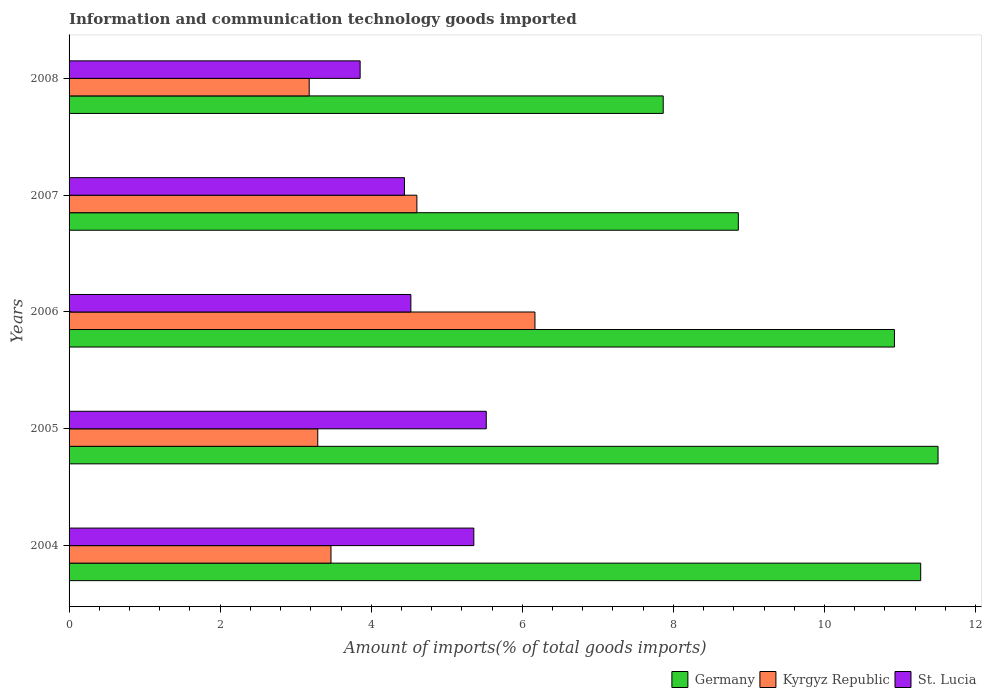How many different coloured bars are there?
Your response must be concise. 3. How many groups of bars are there?
Offer a terse response. 5. Are the number of bars per tick equal to the number of legend labels?
Your answer should be very brief. Yes. What is the label of the 2nd group of bars from the top?
Give a very brief answer. 2007. What is the amount of goods imported in Kyrgyz Republic in 2008?
Provide a short and direct response. 3.18. Across all years, what is the maximum amount of goods imported in Kyrgyz Republic?
Your answer should be very brief. 6.17. Across all years, what is the minimum amount of goods imported in Kyrgyz Republic?
Provide a succinct answer. 3.18. What is the total amount of goods imported in Kyrgyz Republic in the graph?
Provide a succinct answer. 20.71. What is the difference between the amount of goods imported in St. Lucia in 2004 and that in 2006?
Ensure brevity in your answer.  0.83. What is the difference between the amount of goods imported in St. Lucia in 2006 and the amount of goods imported in Germany in 2005?
Your answer should be compact. -6.98. What is the average amount of goods imported in Kyrgyz Republic per year?
Make the answer very short. 4.14. In the year 2008, what is the difference between the amount of goods imported in St. Lucia and amount of goods imported in Kyrgyz Republic?
Your answer should be compact. 0.67. What is the ratio of the amount of goods imported in Germany in 2007 to that in 2008?
Offer a terse response. 1.13. Is the difference between the amount of goods imported in St. Lucia in 2007 and 2008 greater than the difference between the amount of goods imported in Kyrgyz Republic in 2007 and 2008?
Give a very brief answer. No. What is the difference between the highest and the second highest amount of goods imported in Kyrgyz Republic?
Keep it short and to the point. 1.56. What is the difference between the highest and the lowest amount of goods imported in Kyrgyz Republic?
Offer a very short reply. 2.99. In how many years, is the amount of goods imported in St. Lucia greater than the average amount of goods imported in St. Lucia taken over all years?
Your answer should be very brief. 2. Is the sum of the amount of goods imported in St. Lucia in 2004 and 2006 greater than the maximum amount of goods imported in Kyrgyz Republic across all years?
Your answer should be compact. Yes. What does the 3rd bar from the top in 2004 represents?
Give a very brief answer. Germany. Is it the case that in every year, the sum of the amount of goods imported in St. Lucia and amount of goods imported in Germany is greater than the amount of goods imported in Kyrgyz Republic?
Make the answer very short. Yes. Are the values on the major ticks of X-axis written in scientific E-notation?
Provide a short and direct response. No. Does the graph contain any zero values?
Your answer should be very brief. No. Where does the legend appear in the graph?
Keep it short and to the point. Bottom right. What is the title of the graph?
Your answer should be compact. Information and communication technology goods imported. What is the label or title of the X-axis?
Ensure brevity in your answer.  Amount of imports(% of total goods imports). What is the label or title of the Y-axis?
Offer a terse response. Years. What is the Amount of imports(% of total goods imports) in Germany in 2004?
Give a very brief answer. 11.27. What is the Amount of imports(% of total goods imports) of Kyrgyz Republic in 2004?
Your answer should be very brief. 3.47. What is the Amount of imports(% of total goods imports) of St. Lucia in 2004?
Offer a terse response. 5.36. What is the Amount of imports(% of total goods imports) in Germany in 2005?
Offer a very short reply. 11.5. What is the Amount of imports(% of total goods imports) in Kyrgyz Republic in 2005?
Offer a terse response. 3.29. What is the Amount of imports(% of total goods imports) in St. Lucia in 2005?
Keep it short and to the point. 5.52. What is the Amount of imports(% of total goods imports) in Germany in 2006?
Make the answer very short. 10.93. What is the Amount of imports(% of total goods imports) of Kyrgyz Republic in 2006?
Offer a very short reply. 6.17. What is the Amount of imports(% of total goods imports) of St. Lucia in 2006?
Your answer should be very brief. 4.53. What is the Amount of imports(% of total goods imports) of Germany in 2007?
Make the answer very short. 8.86. What is the Amount of imports(% of total goods imports) in Kyrgyz Republic in 2007?
Ensure brevity in your answer.  4.6. What is the Amount of imports(% of total goods imports) of St. Lucia in 2007?
Your response must be concise. 4.44. What is the Amount of imports(% of total goods imports) in Germany in 2008?
Make the answer very short. 7.87. What is the Amount of imports(% of total goods imports) in Kyrgyz Republic in 2008?
Offer a terse response. 3.18. What is the Amount of imports(% of total goods imports) in St. Lucia in 2008?
Make the answer very short. 3.85. Across all years, what is the maximum Amount of imports(% of total goods imports) in Germany?
Provide a short and direct response. 11.5. Across all years, what is the maximum Amount of imports(% of total goods imports) in Kyrgyz Republic?
Provide a succinct answer. 6.17. Across all years, what is the maximum Amount of imports(% of total goods imports) of St. Lucia?
Provide a short and direct response. 5.52. Across all years, what is the minimum Amount of imports(% of total goods imports) in Germany?
Your answer should be very brief. 7.87. Across all years, what is the minimum Amount of imports(% of total goods imports) of Kyrgyz Republic?
Your answer should be very brief. 3.18. Across all years, what is the minimum Amount of imports(% of total goods imports) of St. Lucia?
Keep it short and to the point. 3.85. What is the total Amount of imports(% of total goods imports) in Germany in the graph?
Offer a very short reply. 50.43. What is the total Amount of imports(% of total goods imports) of Kyrgyz Republic in the graph?
Offer a terse response. 20.71. What is the total Amount of imports(% of total goods imports) of St. Lucia in the graph?
Make the answer very short. 23.7. What is the difference between the Amount of imports(% of total goods imports) in Germany in 2004 and that in 2005?
Make the answer very short. -0.23. What is the difference between the Amount of imports(% of total goods imports) of Kyrgyz Republic in 2004 and that in 2005?
Give a very brief answer. 0.17. What is the difference between the Amount of imports(% of total goods imports) in St. Lucia in 2004 and that in 2005?
Your answer should be very brief. -0.16. What is the difference between the Amount of imports(% of total goods imports) of Germany in 2004 and that in 2006?
Provide a succinct answer. 0.35. What is the difference between the Amount of imports(% of total goods imports) in Kyrgyz Republic in 2004 and that in 2006?
Your answer should be compact. -2.7. What is the difference between the Amount of imports(% of total goods imports) in St. Lucia in 2004 and that in 2006?
Give a very brief answer. 0.83. What is the difference between the Amount of imports(% of total goods imports) of Germany in 2004 and that in 2007?
Provide a succinct answer. 2.41. What is the difference between the Amount of imports(% of total goods imports) of Kyrgyz Republic in 2004 and that in 2007?
Your response must be concise. -1.14. What is the difference between the Amount of imports(% of total goods imports) of St. Lucia in 2004 and that in 2007?
Provide a succinct answer. 0.92. What is the difference between the Amount of imports(% of total goods imports) in Germany in 2004 and that in 2008?
Make the answer very short. 3.41. What is the difference between the Amount of imports(% of total goods imports) of Kyrgyz Republic in 2004 and that in 2008?
Keep it short and to the point. 0.29. What is the difference between the Amount of imports(% of total goods imports) in St. Lucia in 2004 and that in 2008?
Give a very brief answer. 1.51. What is the difference between the Amount of imports(% of total goods imports) in Germany in 2005 and that in 2006?
Provide a short and direct response. 0.58. What is the difference between the Amount of imports(% of total goods imports) of Kyrgyz Republic in 2005 and that in 2006?
Offer a terse response. -2.88. What is the difference between the Amount of imports(% of total goods imports) in St. Lucia in 2005 and that in 2006?
Provide a short and direct response. 1. What is the difference between the Amount of imports(% of total goods imports) of Germany in 2005 and that in 2007?
Offer a very short reply. 2.64. What is the difference between the Amount of imports(% of total goods imports) of Kyrgyz Republic in 2005 and that in 2007?
Make the answer very short. -1.31. What is the difference between the Amount of imports(% of total goods imports) of St. Lucia in 2005 and that in 2007?
Your response must be concise. 1.08. What is the difference between the Amount of imports(% of total goods imports) in Germany in 2005 and that in 2008?
Ensure brevity in your answer.  3.64. What is the difference between the Amount of imports(% of total goods imports) of Kyrgyz Republic in 2005 and that in 2008?
Your answer should be very brief. 0.11. What is the difference between the Amount of imports(% of total goods imports) of St. Lucia in 2005 and that in 2008?
Offer a terse response. 1.67. What is the difference between the Amount of imports(% of total goods imports) in Germany in 2006 and that in 2007?
Make the answer very short. 2.07. What is the difference between the Amount of imports(% of total goods imports) of Kyrgyz Republic in 2006 and that in 2007?
Keep it short and to the point. 1.56. What is the difference between the Amount of imports(% of total goods imports) of St. Lucia in 2006 and that in 2007?
Offer a very short reply. 0.08. What is the difference between the Amount of imports(% of total goods imports) of Germany in 2006 and that in 2008?
Keep it short and to the point. 3.06. What is the difference between the Amount of imports(% of total goods imports) in Kyrgyz Republic in 2006 and that in 2008?
Ensure brevity in your answer.  2.99. What is the difference between the Amount of imports(% of total goods imports) of St. Lucia in 2006 and that in 2008?
Provide a succinct answer. 0.67. What is the difference between the Amount of imports(% of total goods imports) of Germany in 2007 and that in 2008?
Provide a succinct answer. 0.99. What is the difference between the Amount of imports(% of total goods imports) of Kyrgyz Republic in 2007 and that in 2008?
Make the answer very short. 1.43. What is the difference between the Amount of imports(% of total goods imports) of St. Lucia in 2007 and that in 2008?
Offer a very short reply. 0.59. What is the difference between the Amount of imports(% of total goods imports) of Germany in 2004 and the Amount of imports(% of total goods imports) of Kyrgyz Republic in 2005?
Offer a terse response. 7.98. What is the difference between the Amount of imports(% of total goods imports) in Germany in 2004 and the Amount of imports(% of total goods imports) in St. Lucia in 2005?
Keep it short and to the point. 5.75. What is the difference between the Amount of imports(% of total goods imports) of Kyrgyz Republic in 2004 and the Amount of imports(% of total goods imports) of St. Lucia in 2005?
Your answer should be compact. -2.06. What is the difference between the Amount of imports(% of total goods imports) of Germany in 2004 and the Amount of imports(% of total goods imports) of Kyrgyz Republic in 2006?
Ensure brevity in your answer.  5.11. What is the difference between the Amount of imports(% of total goods imports) in Germany in 2004 and the Amount of imports(% of total goods imports) in St. Lucia in 2006?
Offer a terse response. 6.75. What is the difference between the Amount of imports(% of total goods imports) of Kyrgyz Republic in 2004 and the Amount of imports(% of total goods imports) of St. Lucia in 2006?
Your response must be concise. -1.06. What is the difference between the Amount of imports(% of total goods imports) of Germany in 2004 and the Amount of imports(% of total goods imports) of Kyrgyz Republic in 2007?
Make the answer very short. 6.67. What is the difference between the Amount of imports(% of total goods imports) of Germany in 2004 and the Amount of imports(% of total goods imports) of St. Lucia in 2007?
Make the answer very short. 6.83. What is the difference between the Amount of imports(% of total goods imports) in Kyrgyz Republic in 2004 and the Amount of imports(% of total goods imports) in St. Lucia in 2007?
Your answer should be compact. -0.97. What is the difference between the Amount of imports(% of total goods imports) of Germany in 2004 and the Amount of imports(% of total goods imports) of Kyrgyz Republic in 2008?
Keep it short and to the point. 8.1. What is the difference between the Amount of imports(% of total goods imports) of Germany in 2004 and the Amount of imports(% of total goods imports) of St. Lucia in 2008?
Your response must be concise. 7.42. What is the difference between the Amount of imports(% of total goods imports) in Kyrgyz Republic in 2004 and the Amount of imports(% of total goods imports) in St. Lucia in 2008?
Offer a terse response. -0.39. What is the difference between the Amount of imports(% of total goods imports) in Germany in 2005 and the Amount of imports(% of total goods imports) in Kyrgyz Republic in 2006?
Your answer should be compact. 5.34. What is the difference between the Amount of imports(% of total goods imports) of Germany in 2005 and the Amount of imports(% of total goods imports) of St. Lucia in 2006?
Provide a succinct answer. 6.98. What is the difference between the Amount of imports(% of total goods imports) in Kyrgyz Republic in 2005 and the Amount of imports(% of total goods imports) in St. Lucia in 2006?
Provide a succinct answer. -1.23. What is the difference between the Amount of imports(% of total goods imports) of Germany in 2005 and the Amount of imports(% of total goods imports) of Kyrgyz Republic in 2007?
Provide a short and direct response. 6.9. What is the difference between the Amount of imports(% of total goods imports) of Germany in 2005 and the Amount of imports(% of total goods imports) of St. Lucia in 2007?
Provide a short and direct response. 7.06. What is the difference between the Amount of imports(% of total goods imports) of Kyrgyz Republic in 2005 and the Amount of imports(% of total goods imports) of St. Lucia in 2007?
Ensure brevity in your answer.  -1.15. What is the difference between the Amount of imports(% of total goods imports) in Germany in 2005 and the Amount of imports(% of total goods imports) in Kyrgyz Republic in 2008?
Make the answer very short. 8.32. What is the difference between the Amount of imports(% of total goods imports) in Germany in 2005 and the Amount of imports(% of total goods imports) in St. Lucia in 2008?
Keep it short and to the point. 7.65. What is the difference between the Amount of imports(% of total goods imports) in Kyrgyz Republic in 2005 and the Amount of imports(% of total goods imports) in St. Lucia in 2008?
Keep it short and to the point. -0.56. What is the difference between the Amount of imports(% of total goods imports) in Germany in 2006 and the Amount of imports(% of total goods imports) in Kyrgyz Republic in 2007?
Provide a succinct answer. 6.32. What is the difference between the Amount of imports(% of total goods imports) of Germany in 2006 and the Amount of imports(% of total goods imports) of St. Lucia in 2007?
Keep it short and to the point. 6.49. What is the difference between the Amount of imports(% of total goods imports) in Kyrgyz Republic in 2006 and the Amount of imports(% of total goods imports) in St. Lucia in 2007?
Keep it short and to the point. 1.73. What is the difference between the Amount of imports(% of total goods imports) of Germany in 2006 and the Amount of imports(% of total goods imports) of Kyrgyz Republic in 2008?
Provide a short and direct response. 7.75. What is the difference between the Amount of imports(% of total goods imports) in Germany in 2006 and the Amount of imports(% of total goods imports) in St. Lucia in 2008?
Ensure brevity in your answer.  7.07. What is the difference between the Amount of imports(% of total goods imports) in Kyrgyz Republic in 2006 and the Amount of imports(% of total goods imports) in St. Lucia in 2008?
Offer a terse response. 2.31. What is the difference between the Amount of imports(% of total goods imports) of Germany in 2007 and the Amount of imports(% of total goods imports) of Kyrgyz Republic in 2008?
Provide a short and direct response. 5.68. What is the difference between the Amount of imports(% of total goods imports) of Germany in 2007 and the Amount of imports(% of total goods imports) of St. Lucia in 2008?
Offer a terse response. 5.01. What is the difference between the Amount of imports(% of total goods imports) of Kyrgyz Republic in 2007 and the Amount of imports(% of total goods imports) of St. Lucia in 2008?
Your answer should be compact. 0.75. What is the average Amount of imports(% of total goods imports) in Germany per year?
Offer a terse response. 10.09. What is the average Amount of imports(% of total goods imports) of Kyrgyz Republic per year?
Ensure brevity in your answer.  4.14. What is the average Amount of imports(% of total goods imports) in St. Lucia per year?
Your answer should be very brief. 4.74. In the year 2004, what is the difference between the Amount of imports(% of total goods imports) of Germany and Amount of imports(% of total goods imports) of Kyrgyz Republic?
Give a very brief answer. 7.81. In the year 2004, what is the difference between the Amount of imports(% of total goods imports) in Germany and Amount of imports(% of total goods imports) in St. Lucia?
Ensure brevity in your answer.  5.92. In the year 2004, what is the difference between the Amount of imports(% of total goods imports) in Kyrgyz Republic and Amount of imports(% of total goods imports) in St. Lucia?
Ensure brevity in your answer.  -1.89. In the year 2005, what is the difference between the Amount of imports(% of total goods imports) of Germany and Amount of imports(% of total goods imports) of Kyrgyz Republic?
Ensure brevity in your answer.  8.21. In the year 2005, what is the difference between the Amount of imports(% of total goods imports) in Germany and Amount of imports(% of total goods imports) in St. Lucia?
Your answer should be very brief. 5.98. In the year 2005, what is the difference between the Amount of imports(% of total goods imports) of Kyrgyz Republic and Amount of imports(% of total goods imports) of St. Lucia?
Offer a terse response. -2.23. In the year 2006, what is the difference between the Amount of imports(% of total goods imports) of Germany and Amount of imports(% of total goods imports) of Kyrgyz Republic?
Your answer should be compact. 4.76. In the year 2006, what is the difference between the Amount of imports(% of total goods imports) of Germany and Amount of imports(% of total goods imports) of St. Lucia?
Your answer should be very brief. 6.4. In the year 2006, what is the difference between the Amount of imports(% of total goods imports) in Kyrgyz Republic and Amount of imports(% of total goods imports) in St. Lucia?
Keep it short and to the point. 1.64. In the year 2007, what is the difference between the Amount of imports(% of total goods imports) in Germany and Amount of imports(% of total goods imports) in Kyrgyz Republic?
Offer a terse response. 4.26. In the year 2007, what is the difference between the Amount of imports(% of total goods imports) of Germany and Amount of imports(% of total goods imports) of St. Lucia?
Your answer should be compact. 4.42. In the year 2007, what is the difference between the Amount of imports(% of total goods imports) in Kyrgyz Republic and Amount of imports(% of total goods imports) in St. Lucia?
Provide a succinct answer. 0.16. In the year 2008, what is the difference between the Amount of imports(% of total goods imports) in Germany and Amount of imports(% of total goods imports) in Kyrgyz Republic?
Provide a succinct answer. 4.69. In the year 2008, what is the difference between the Amount of imports(% of total goods imports) of Germany and Amount of imports(% of total goods imports) of St. Lucia?
Keep it short and to the point. 4.01. In the year 2008, what is the difference between the Amount of imports(% of total goods imports) in Kyrgyz Republic and Amount of imports(% of total goods imports) in St. Lucia?
Your answer should be very brief. -0.67. What is the ratio of the Amount of imports(% of total goods imports) of Germany in 2004 to that in 2005?
Make the answer very short. 0.98. What is the ratio of the Amount of imports(% of total goods imports) in Kyrgyz Republic in 2004 to that in 2005?
Ensure brevity in your answer.  1.05. What is the ratio of the Amount of imports(% of total goods imports) in St. Lucia in 2004 to that in 2005?
Your response must be concise. 0.97. What is the ratio of the Amount of imports(% of total goods imports) in Germany in 2004 to that in 2006?
Your answer should be very brief. 1.03. What is the ratio of the Amount of imports(% of total goods imports) in Kyrgyz Republic in 2004 to that in 2006?
Your response must be concise. 0.56. What is the ratio of the Amount of imports(% of total goods imports) of St. Lucia in 2004 to that in 2006?
Your response must be concise. 1.18. What is the ratio of the Amount of imports(% of total goods imports) in Germany in 2004 to that in 2007?
Offer a very short reply. 1.27. What is the ratio of the Amount of imports(% of total goods imports) in Kyrgyz Republic in 2004 to that in 2007?
Offer a very short reply. 0.75. What is the ratio of the Amount of imports(% of total goods imports) in St. Lucia in 2004 to that in 2007?
Provide a succinct answer. 1.21. What is the ratio of the Amount of imports(% of total goods imports) of Germany in 2004 to that in 2008?
Keep it short and to the point. 1.43. What is the ratio of the Amount of imports(% of total goods imports) of Kyrgyz Republic in 2004 to that in 2008?
Ensure brevity in your answer.  1.09. What is the ratio of the Amount of imports(% of total goods imports) of St. Lucia in 2004 to that in 2008?
Your response must be concise. 1.39. What is the ratio of the Amount of imports(% of total goods imports) of Germany in 2005 to that in 2006?
Your answer should be very brief. 1.05. What is the ratio of the Amount of imports(% of total goods imports) of Kyrgyz Republic in 2005 to that in 2006?
Provide a succinct answer. 0.53. What is the ratio of the Amount of imports(% of total goods imports) of St. Lucia in 2005 to that in 2006?
Provide a short and direct response. 1.22. What is the ratio of the Amount of imports(% of total goods imports) in Germany in 2005 to that in 2007?
Make the answer very short. 1.3. What is the ratio of the Amount of imports(% of total goods imports) in Kyrgyz Republic in 2005 to that in 2007?
Provide a short and direct response. 0.71. What is the ratio of the Amount of imports(% of total goods imports) of St. Lucia in 2005 to that in 2007?
Give a very brief answer. 1.24. What is the ratio of the Amount of imports(% of total goods imports) in Germany in 2005 to that in 2008?
Provide a succinct answer. 1.46. What is the ratio of the Amount of imports(% of total goods imports) in Kyrgyz Republic in 2005 to that in 2008?
Make the answer very short. 1.04. What is the ratio of the Amount of imports(% of total goods imports) in St. Lucia in 2005 to that in 2008?
Your answer should be compact. 1.43. What is the ratio of the Amount of imports(% of total goods imports) of Germany in 2006 to that in 2007?
Your answer should be very brief. 1.23. What is the ratio of the Amount of imports(% of total goods imports) in Kyrgyz Republic in 2006 to that in 2007?
Provide a succinct answer. 1.34. What is the ratio of the Amount of imports(% of total goods imports) in St. Lucia in 2006 to that in 2007?
Offer a very short reply. 1.02. What is the ratio of the Amount of imports(% of total goods imports) in Germany in 2006 to that in 2008?
Provide a short and direct response. 1.39. What is the ratio of the Amount of imports(% of total goods imports) in Kyrgyz Republic in 2006 to that in 2008?
Make the answer very short. 1.94. What is the ratio of the Amount of imports(% of total goods imports) of St. Lucia in 2006 to that in 2008?
Your response must be concise. 1.17. What is the ratio of the Amount of imports(% of total goods imports) of Germany in 2007 to that in 2008?
Make the answer very short. 1.13. What is the ratio of the Amount of imports(% of total goods imports) in Kyrgyz Republic in 2007 to that in 2008?
Your response must be concise. 1.45. What is the ratio of the Amount of imports(% of total goods imports) of St. Lucia in 2007 to that in 2008?
Keep it short and to the point. 1.15. What is the difference between the highest and the second highest Amount of imports(% of total goods imports) in Germany?
Keep it short and to the point. 0.23. What is the difference between the highest and the second highest Amount of imports(% of total goods imports) in Kyrgyz Republic?
Your answer should be very brief. 1.56. What is the difference between the highest and the second highest Amount of imports(% of total goods imports) of St. Lucia?
Offer a very short reply. 0.16. What is the difference between the highest and the lowest Amount of imports(% of total goods imports) of Germany?
Provide a succinct answer. 3.64. What is the difference between the highest and the lowest Amount of imports(% of total goods imports) of Kyrgyz Republic?
Your answer should be very brief. 2.99. What is the difference between the highest and the lowest Amount of imports(% of total goods imports) in St. Lucia?
Your response must be concise. 1.67. 